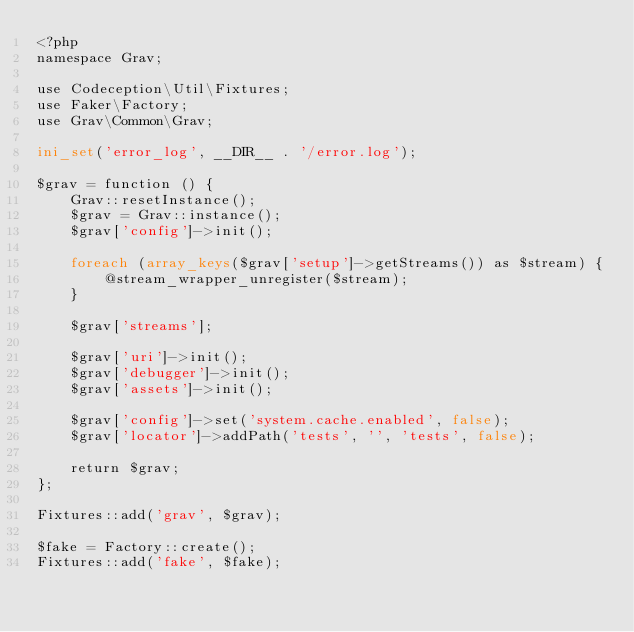Convert code to text. <code><loc_0><loc_0><loc_500><loc_500><_PHP_><?php
namespace Grav;

use Codeception\Util\Fixtures;
use Faker\Factory;
use Grav\Common\Grav;

ini_set('error_log', __DIR__ . '/error.log');

$grav = function () {
    Grav::resetInstance();
    $grav = Grav::instance();
    $grav['config']->init();

    foreach (array_keys($grav['setup']->getStreams()) as $stream) {
        @stream_wrapper_unregister($stream);
    }

    $grav['streams'];

    $grav['uri']->init();
    $grav['debugger']->init();
    $grav['assets']->init();

    $grav['config']->set('system.cache.enabled', false);
    $grav['locator']->addPath('tests', '', 'tests', false);

    return $grav;
};

Fixtures::add('grav', $grav);

$fake = Factory::create();
Fixtures::add('fake', $fake);
</code> 